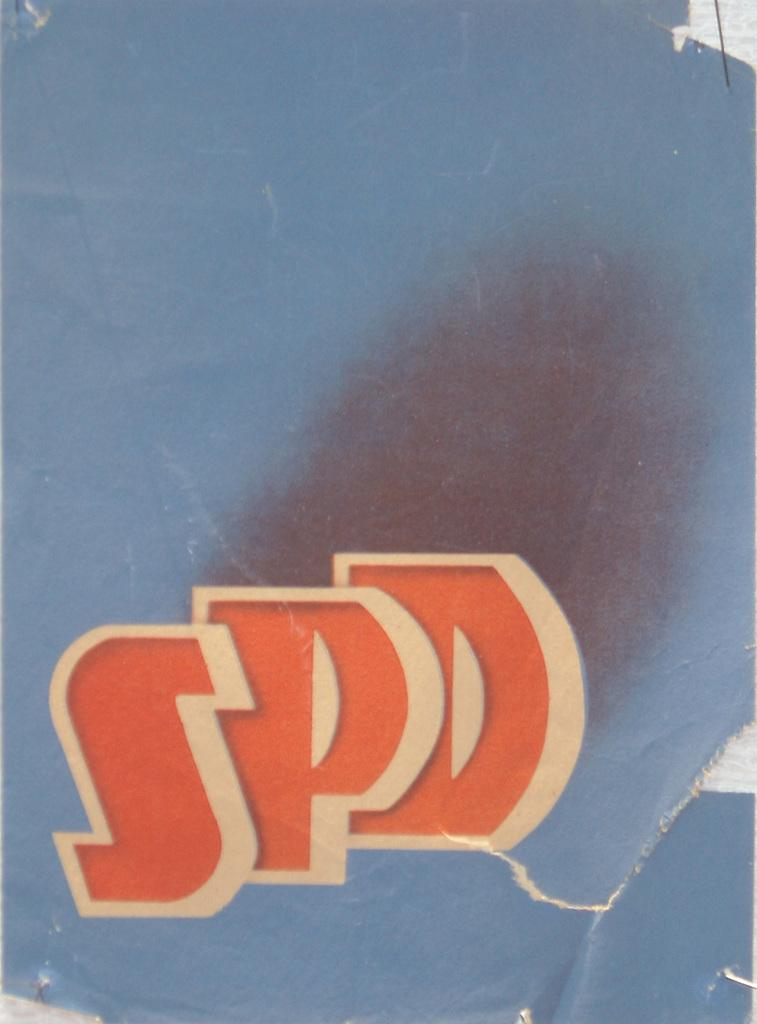Provide a one-sentence caption for the provided image. Three letters SPD are pictured on a blue back ground. 